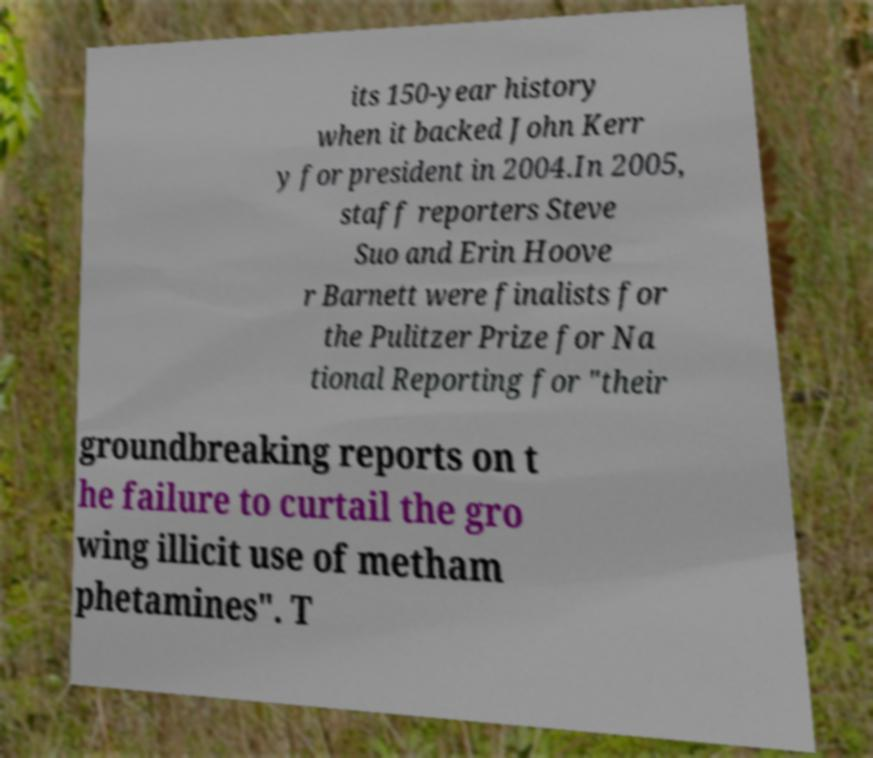Could you extract and type out the text from this image? its 150-year history when it backed John Kerr y for president in 2004.In 2005, staff reporters Steve Suo and Erin Hoove r Barnett were finalists for the Pulitzer Prize for Na tional Reporting for "their groundbreaking reports on t he failure to curtail the gro wing illicit use of metham phetamines". T 